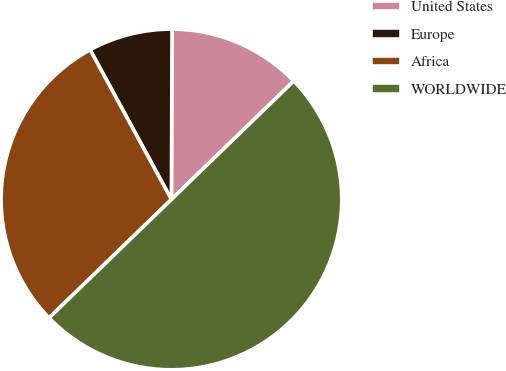Convert chart to OTSL. <chart><loc_0><loc_0><loc_500><loc_500><pie_chart><fcel>United States<fcel>Europe<fcel>Africa<fcel>WORLDWIDE<nl><fcel>12.7%<fcel>7.98%<fcel>29.32%<fcel>50.0%<nl></chart> 